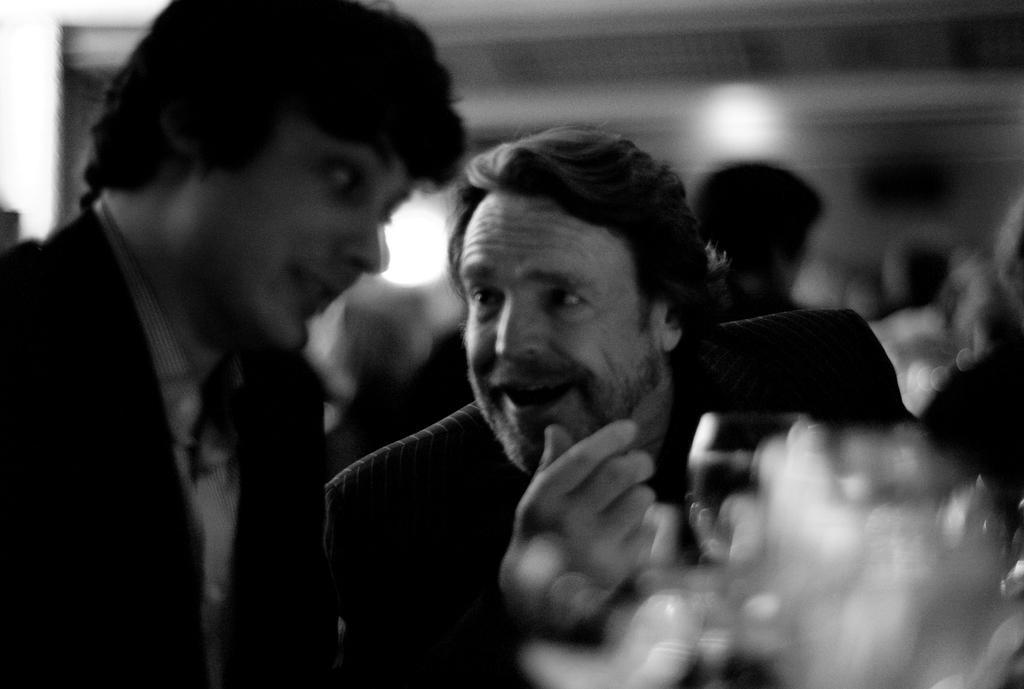Could you give a brief overview of what you see in this image? This is a black and white picture, there are two men sitting in the front with wine glasses on the table and behind there are few persons visible. 